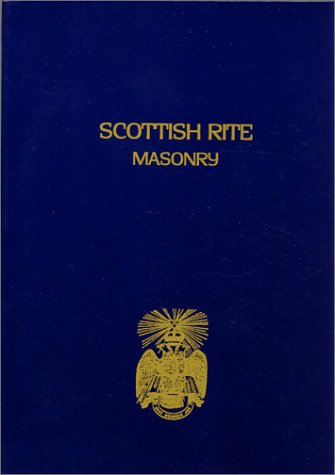Who wrote this book? The author of the book, clearly shown on the cover, is John Blanchard. 